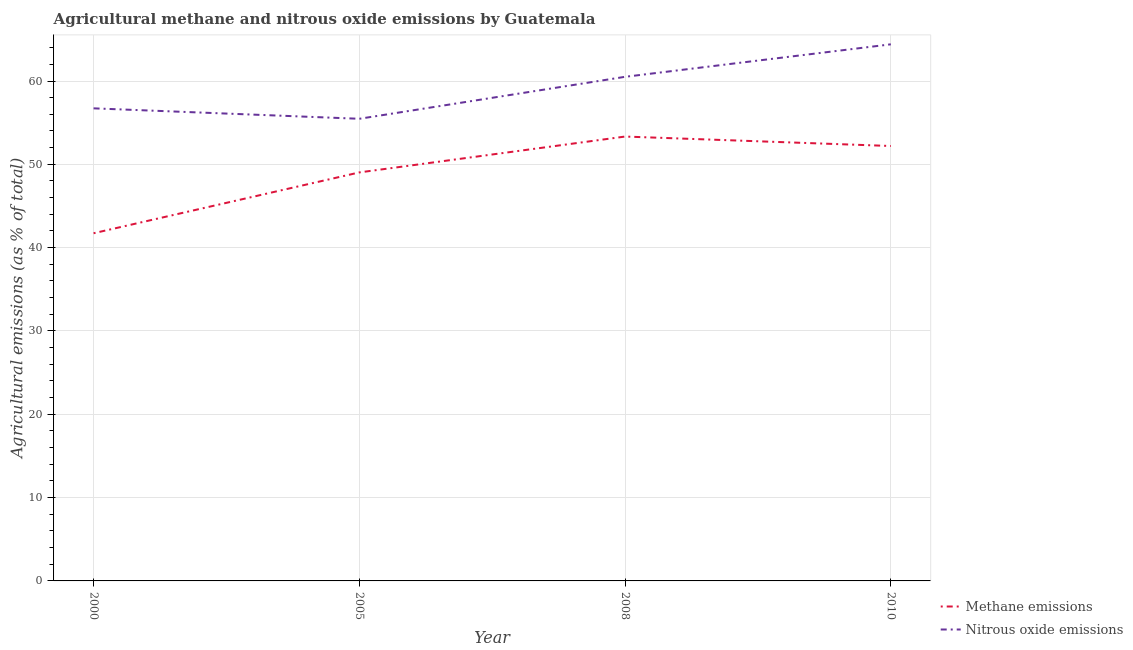Does the line corresponding to amount of nitrous oxide emissions intersect with the line corresponding to amount of methane emissions?
Provide a succinct answer. No. Is the number of lines equal to the number of legend labels?
Provide a short and direct response. Yes. What is the amount of nitrous oxide emissions in 2008?
Make the answer very short. 60.5. Across all years, what is the maximum amount of methane emissions?
Your response must be concise. 53.33. Across all years, what is the minimum amount of methane emissions?
Ensure brevity in your answer.  41.73. In which year was the amount of methane emissions maximum?
Keep it short and to the point. 2008. What is the total amount of nitrous oxide emissions in the graph?
Provide a succinct answer. 237.09. What is the difference between the amount of nitrous oxide emissions in 2000 and that in 2010?
Ensure brevity in your answer.  -7.68. What is the difference between the amount of methane emissions in 2005 and the amount of nitrous oxide emissions in 2000?
Make the answer very short. -7.69. What is the average amount of methane emissions per year?
Give a very brief answer. 49.07. In the year 2005, what is the difference between the amount of methane emissions and amount of nitrous oxide emissions?
Provide a succinct answer. -6.44. What is the ratio of the amount of nitrous oxide emissions in 2008 to that in 2010?
Your answer should be compact. 0.94. Is the amount of methane emissions in 2005 less than that in 2010?
Ensure brevity in your answer.  Yes. Is the difference between the amount of methane emissions in 2000 and 2010 greater than the difference between the amount of nitrous oxide emissions in 2000 and 2010?
Ensure brevity in your answer.  No. What is the difference between the highest and the second highest amount of nitrous oxide emissions?
Offer a very short reply. 3.9. What is the difference between the highest and the lowest amount of methane emissions?
Keep it short and to the point. 11.61. Is the sum of the amount of nitrous oxide emissions in 2008 and 2010 greater than the maximum amount of methane emissions across all years?
Provide a short and direct response. Yes. Does the amount of nitrous oxide emissions monotonically increase over the years?
Offer a very short reply. No. Is the amount of methane emissions strictly greater than the amount of nitrous oxide emissions over the years?
Offer a terse response. No. Is the amount of methane emissions strictly less than the amount of nitrous oxide emissions over the years?
Give a very brief answer. Yes. How many lines are there?
Make the answer very short. 2. How many years are there in the graph?
Provide a succinct answer. 4. Does the graph contain grids?
Make the answer very short. Yes. How many legend labels are there?
Your answer should be compact. 2. How are the legend labels stacked?
Your answer should be very brief. Vertical. What is the title of the graph?
Offer a terse response. Agricultural methane and nitrous oxide emissions by Guatemala. Does "Borrowers" appear as one of the legend labels in the graph?
Ensure brevity in your answer.  No. What is the label or title of the Y-axis?
Your answer should be very brief. Agricultural emissions (as % of total). What is the Agricultural emissions (as % of total) of Methane emissions in 2000?
Your answer should be very brief. 41.73. What is the Agricultural emissions (as % of total) of Nitrous oxide emissions in 2000?
Your answer should be compact. 56.72. What is the Agricultural emissions (as % of total) of Methane emissions in 2005?
Ensure brevity in your answer.  49.03. What is the Agricultural emissions (as % of total) in Nitrous oxide emissions in 2005?
Your answer should be compact. 55.47. What is the Agricultural emissions (as % of total) in Methane emissions in 2008?
Your response must be concise. 53.33. What is the Agricultural emissions (as % of total) of Nitrous oxide emissions in 2008?
Provide a short and direct response. 60.5. What is the Agricultural emissions (as % of total) in Methane emissions in 2010?
Your response must be concise. 52.2. What is the Agricultural emissions (as % of total) in Nitrous oxide emissions in 2010?
Provide a short and direct response. 64.4. Across all years, what is the maximum Agricultural emissions (as % of total) in Methane emissions?
Provide a short and direct response. 53.33. Across all years, what is the maximum Agricultural emissions (as % of total) in Nitrous oxide emissions?
Provide a short and direct response. 64.4. Across all years, what is the minimum Agricultural emissions (as % of total) of Methane emissions?
Provide a short and direct response. 41.73. Across all years, what is the minimum Agricultural emissions (as % of total) in Nitrous oxide emissions?
Offer a very short reply. 55.47. What is the total Agricultural emissions (as % of total) of Methane emissions in the graph?
Give a very brief answer. 196.29. What is the total Agricultural emissions (as % of total) of Nitrous oxide emissions in the graph?
Your answer should be very brief. 237.09. What is the difference between the Agricultural emissions (as % of total) in Methane emissions in 2000 and that in 2005?
Provide a short and direct response. -7.3. What is the difference between the Agricultural emissions (as % of total) in Nitrous oxide emissions in 2000 and that in 2005?
Your response must be concise. 1.25. What is the difference between the Agricultural emissions (as % of total) of Methane emissions in 2000 and that in 2008?
Make the answer very short. -11.61. What is the difference between the Agricultural emissions (as % of total) of Nitrous oxide emissions in 2000 and that in 2008?
Your answer should be very brief. -3.78. What is the difference between the Agricultural emissions (as % of total) of Methane emissions in 2000 and that in 2010?
Provide a short and direct response. -10.47. What is the difference between the Agricultural emissions (as % of total) of Nitrous oxide emissions in 2000 and that in 2010?
Offer a terse response. -7.68. What is the difference between the Agricultural emissions (as % of total) of Methane emissions in 2005 and that in 2008?
Provide a succinct answer. -4.31. What is the difference between the Agricultural emissions (as % of total) of Nitrous oxide emissions in 2005 and that in 2008?
Your answer should be very brief. -5.04. What is the difference between the Agricultural emissions (as % of total) of Methane emissions in 2005 and that in 2010?
Provide a short and direct response. -3.17. What is the difference between the Agricultural emissions (as % of total) of Nitrous oxide emissions in 2005 and that in 2010?
Your answer should be compact. -8.94. What is the difference between the Agricultural emissions (as % of total) in Methane emissions in 2008 and that in 2010?
Ensure brevity in your answer.  1.13. What is the difference between the Agricultural emissions (as % of total) of Nitrous oxide emissions in 2008 and that in 2010?
Your answer should be very brief. -3.9. What is the difference between the Agricultural emissions (as % of total) of Methane emissions in 2000 and the Agricultural emissions (as % of total) of Nitrous oxide emissions in 2005?
Your response must be concise. -13.74. What is the difference between the Agricultural emissions (as % of total) of Methane emissions in 2000 and the Agricultural emissions (as % of total) of Nitrous oxide emissions in 2008?
Offer a very short reply. -18.78. What is the difference between the Agricultural emissions (as % of total) of Methane emissions in 2000 and the Agricultural emissions (as % of total) of Nitrous oxide emissions in 2010?
Ensure brevity in your answer.  -22.67. What is the difference between the Agricultural emissions (as % of total) in Methane emissions in 2005 and the Agricultural emissions (as % of total) in Nitrous oxide emissions in 2008?
Offer a very short reply. -11.47. What is the difference between the Agricultural emissions (as % of total) of Methane emissions in 2005 and the Agricultural emissions (as % of total) of Nitrous oxide emissions in 2010?
Your response must be concise. -15.37. What is the difference between the Agricultural emissions (as % of total) of Methane emissions in 2008 and the Agricultural emissions (as % of total) of Nitrous oxide emissions in 2010?
Ensure brevity in your answer.  -11.07. What is the average Agricultural emissions (as % of total) in Methane emissions per year?
Provide a succinct answer. 49.07. What is the average Agricultural emissions (as % of total) in Nitrous oxide emissions per year?
Ensure brevity in your answer.  59.27. In the year 2000, what is the difference between the Agricultural emissions (as % of total) of Methane emissions and Agricultural emissions (as % of total) of Nitrous oxide emissions?
Provide a short and direct response. -14.99. In the year 2005, what is the difference between the Agricultural emissions (as % of total) in Methane emissions and Agricultural emissions (as % of total) in Nitrous oxide emissions?
Provide a succinct answer. -6.44. In the year 2008, what is the difference between the Agricultural emissions (as % of total) of Methane emissions and Agricultural emissions (as % of total) of Nitrous oxide emissions?
Your answer should be very brief. -7.17. In the year 2010, what is the difference between the Agricultural emissions (as % of total) of Methane emissions and Agricultural emissions (as % of total) of Nitrous oxide emissions?
Give a very brief answer. -12.2. What is the ratio of the Agricultural emissions (as % of total) in Methane emissions in 2000 to that in 2005?
Make the answer very short. 0.85. What is the ratio of the Agricultural emissions (as % of total) in Nitrous oxide emissions in 2000 to that in 2005?
Make the answer very short. 1.02. What is the ratio of the Agricultural emissions (as % of total) in Methane emissions in 2000 to that in 2008?
Make the answer very short. 0.78. What is the ratio of the Agricultural emissions (as % of total) in Methane emissions in 2000 to that in 2010?
Your answer should be compact. 0.8. What is the ratio of the Agricultural emissions (as % of total) in Nitrous oxide emissions in 2000 to that in 2010?
Make the answer very short. 0.88. What is the ratio of the Agricultural emissions (as % of total) in Methane emissions in 2005 to that in 2008?
Your answer should be compact. 0.92. What is the ratio of the Agricultural emissions (as % of total) in Nitrous oxide emissions in 2005 to that in 2008?
Offer a terse response. 0.92. What is the ratio of the Agricultural emissions (as % of total) in Methane emissions in 2005 to that in 2010?
Ensure brevity in your answer.  0.94. What is the ratio of the Agricultural emissions (as % of total) of Nitrous oxide emissions in 2005 to that in 2010?
Your response must be concise. 0.86. What is the ratio of the Agricultural emissions (as % of total) of Methane emissions in 2008 to that in 2010?
Provide a succinct answer. 1.02. What is the ratio of the Agricultural emissions (as % of total) in Nitrous oxide emissions in 2008 to that in 2010?
Keep it short and to the point. 0.94. What is the difference between the highest and the second highest Agricultural emissions (as % of total) in Methane emissions?
Keep it short and to the point. 1.13. What is the difference between the highest and the second highest Agricultural emissions (as % of total) of Nitrous oxide emissions?
Offer a terse response. 3.9. What is the difference between the highest and the lowest Agricultural emissions (as % of total) in Methane emissions?
Your answer should be compact. 11.61. What is the difference between the highest and the lowest Agricultural emissions (as % of total) of Nitrous oxide emissions?
Keep it short and to the point. 8.94. 